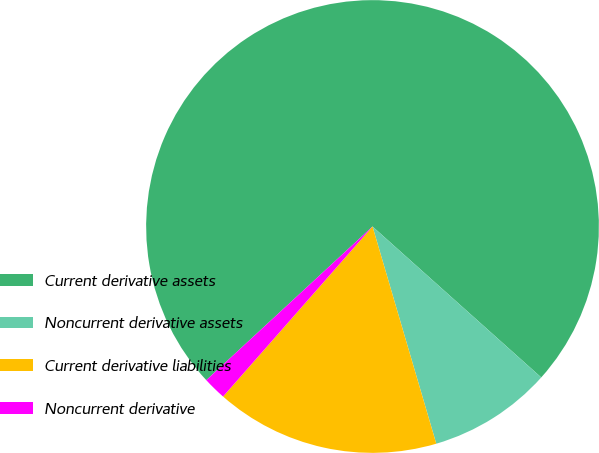Convert chart. <chart><loc_0><loc_0><loc_500><loc_500><pie_chart><fcel>Current derivative assets<fcel>Noncurrent derivative assets<fcel>Current derivative liabilities<fcel>Noncurrent derivative<nl><fcel>73.49%<fcel>8.84%<fcel>16.02%<fcel>1.65%<nl></chart> 